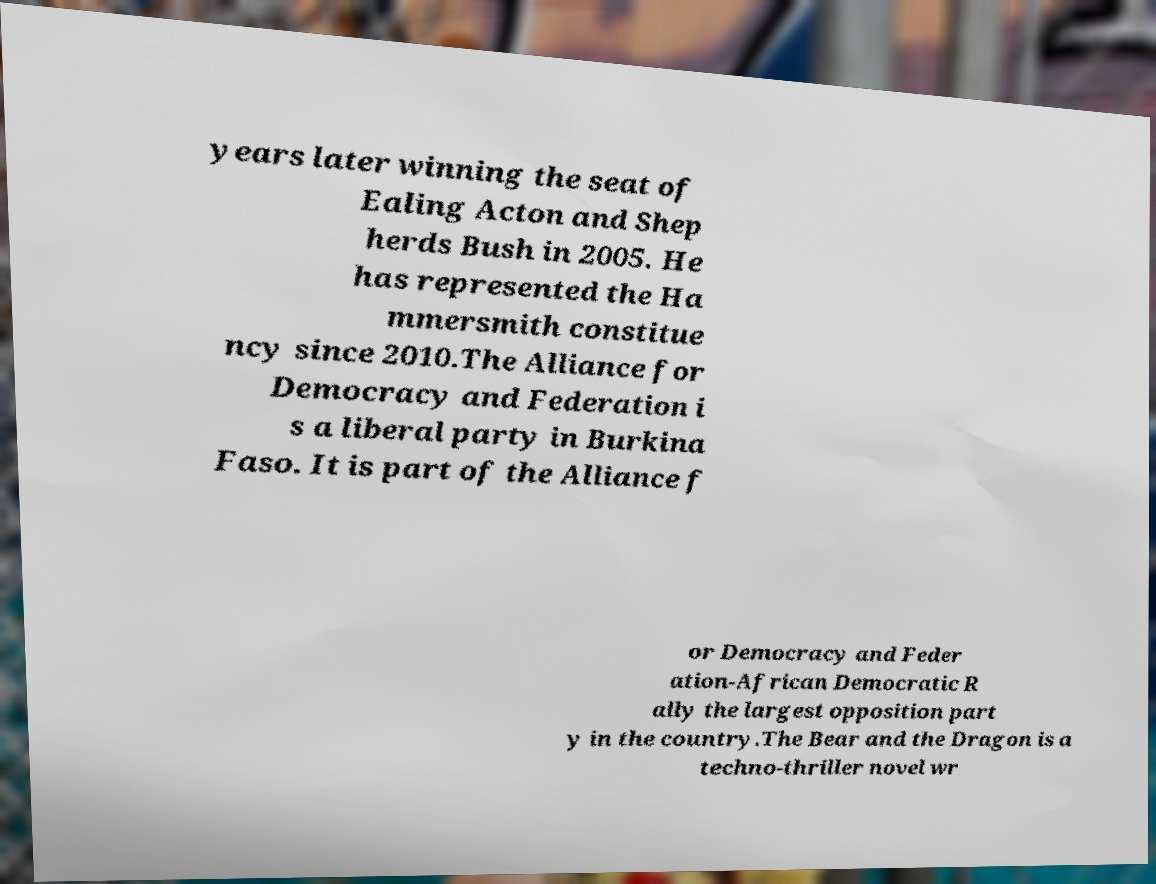Could you assist in decoding the text presented in this image and type it out clearly? years later winning the seat of Ealing Acton and Shep herds Bush in 2005. He has represented the Ha mmersmith constitue ncy since 2010.The Alliance for Democracy and Federation i s a liberal party in Burkina Faso. It is part of the Alliance f or Democracy and Feder ation-African Democratic R ally the largest opposition part y in the country.The Bear and the Dragon is a techno-thriller novel wr 